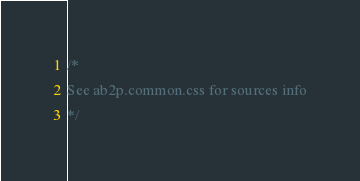Convert code to text. <code><loc_0><loc_0><loc_500><loc_500><_CSS_>/*
See ab2p.common.css for sources info
*/</code> 